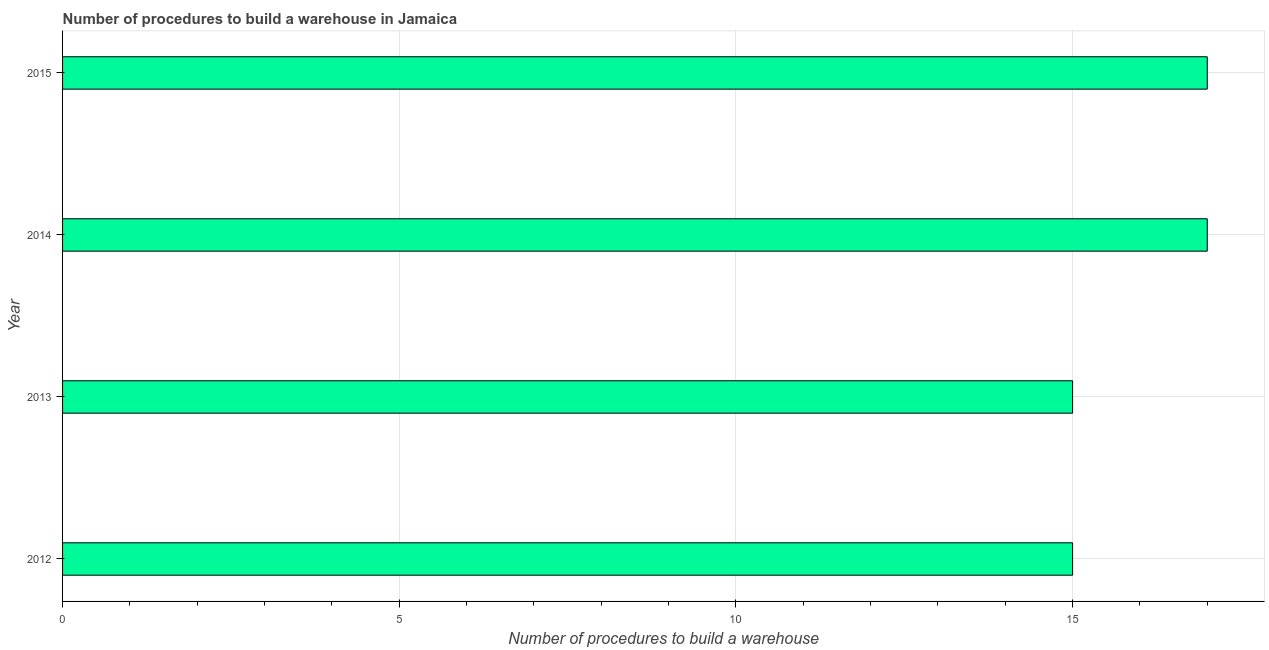What is the title of the graph?
Your answer should be very brief. Number of procedures to build a warehouse in Jamaica. What is the label or title of the X-axis?
Offer a very short reply. Number of procedures to build a warehouse. What is the number of procedures to build a warehouse in 2012?
Offer a terse response. 15. Across all years, what is the maximum number of procedures to build a warehouse?
Ensure brevity in your answer.  17. Across all years, what is the minimum number of procedures to build a warehouse?
Offer a very short reply. 15. In which year was the number of procedures to build a warehouse maximum?
Your response must be concise. 2014. In which year was the number of procedures to build a warehouse minimum?
Offer a very short reply. 2012. What is the sum of the number of procedures to build a warehouse?
Provide a succinct answer. 64. In how many years, is the number of procedures to build a warehouse greater than 4 ?
Give a very brief answer. 4. Do a majority of the years between 2013 and 2012 (inclusive) have number of procedures to build a warehouse greater than 10 ?
Provide a succinct answer. No. What is the ratio of the number of procedures to build a warehouse in 2012 to that in 2013?
Provide a short and direct response. 1. Is the difference between the number of procedures to build a warehouse in 2013 and 2014 greater than the difference between any two years?
Offer a very short reply. Yes. How many years are there in the graph?
Offer a very short reply. 4. What is the difference between two consecutive major ticks on the X-axis?
Your response must be concise. 5. What is the Number of procedures to build a warehouse in 2012?
Make the answer very short. 15. What is the Number of procedures to build a warehouse of 2013?
Provide a succinct answer. 15. What is the Number of procedures to build a warehouse in 2015?
Give a very brief answer. 17. What is the difference between the Number of procedures to build a warehouse in 2013 and 2014?
Your response must be concise. -2. What is the ratio of the Number of procedures to build a warehouse in 2012 to that in 2014?
Offer a very short reply. 0.88. What is the ratio of the Number of procedures to build a warehouse in 2012 to that in 2015?
Provide a short and direct response. 0.88. What is the ratio of the Number of procedures to build a warehouse in 2013 to that in 2014?
Offer a very short reply. 0.88. What is the ratio of the Number of procedures to build a warehouse in 2013 to that in 2015?
Your response must be concise. 0.88. What is the ratio of the Number of procedures to build a warehouse in 2014 to that in 2015?
Keep it short and to the point. 1. 